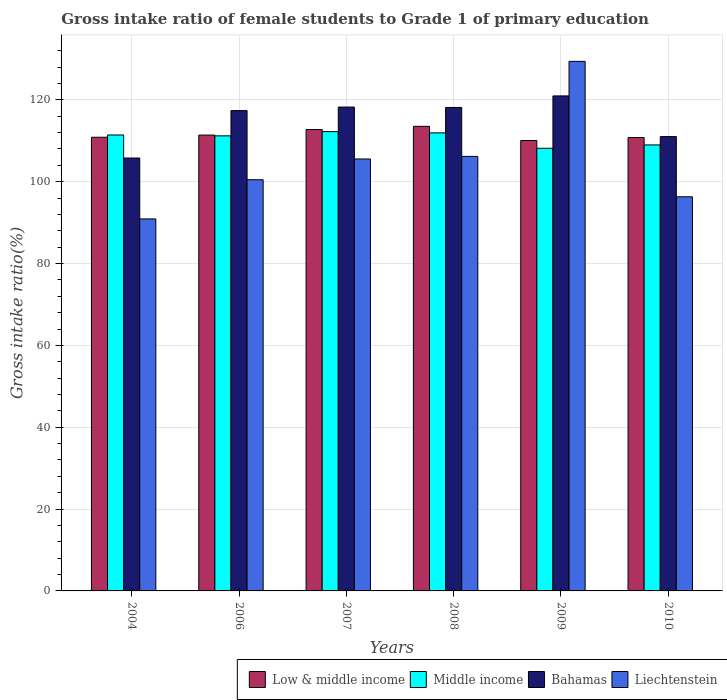Are the number of bars per tick equal to the number of legend labels?
Offer a terse response. Yes. Are the number of bars on each tick of the X-axis equal?
Make the answer very short. Yes. How many bars are there on the 3rd tick from the left?
Make the answer very short. 4. In how many cases, is the number of bars for a given year not equal to the number of legend labels?
Provide a succinct answer. 0. What is the gross intake ratio in Low & middle income in 2006?
Keep it short and to the point. 111.4. Across all years, what is the maximum gross intake ratio in Liechtenstein?
Offer a very short reply. 129.41. Across all years, what is the minimum gross intake ratio in Bahamas?
Make the answer very short. 105.79. What is the total gross intake ratio in Low & middle income in the graph?
Ensure brevity in your answer.  669.41. What is the difference between the gross intake ratio in Low & middle income in 2006 and that in 2008?
Offer a very short reply. -2.14. What is the difference between the gross intake ratio in Liechtenstein in 2007 and the gross intake ratio in Low & middle income in 2010?
Your answer should be compact. -5.24. What is the average gross intake ratio in Bahamas per year?
Give a very brief answer. 115.26. In the year 2006, what is the difference between the gross intake ratio in Middle income and gross intake ratio in Bahamas?
Provide a succinct answer. -6.17. In how many years, is the gross intake ratio in Low & middle income greater than 116 %?
Keep it short and to the point. 0. What is the ratio of the gross intake ratio in Low & middle income in 2004 to that in 2006?
Offer a terse response. 1. Is the difference between the gross intake ratio in Middle income in 2004 and 2007 greater than the difference between the gross intake ratio in Bahamas in 2004 and 2007?
Offer a terse response. Yes. What is the difference between the highest and the second highest gross intake ratio in Middle income?
Keep it short and to the point. 0.31. What is the difference between the highest and the lowest gross intake ratio in Middle income?
Your answer should be very brief. 4.08. In how many years, is the gross intake ratio in Middle income greater than the average gross intake ratio in Middle income taken over all years?
Ensure brevity in your answer.  4. Is the sum of the gross intake ratio in Middle income in 2009 and 2010 greater than the maximum gross intake ratio in Low & middle income across all years?
Ensure brevity in your answer.  Yes. Is it the case that in every year, the sum of the gross intake ratio in Liechtenstein and gross intake ratio in Low & middle income is greater than the sum of gross intake ratio in Bahamas and gross intake ratio in Middle income?
Keep it short and to the point. No. What does the 1st bar from the left in 2007 represents?
Offer a terse response. Low & middle income. Is it the case that in every year, the sum of the gross intake ratio in Middle income and gross intake ratio in Bahamas is greater than the gross intake ratio in Low & middle income?
Ensure brevity in your answer.  Yes. How many bars are there?
Provide a short and direct response. 24. Are all the bars in the graph horizontal?
Your response must be concise. No. What is the difference between two consecutive major ticks on the Y-axis?
Give a very brief answer. 20. Does the graph contain any zero values?
Keep it short and to the point. No. How many legend labels are there?
Give a very brief answer. 4. What is the title of the graph?
Make the answer very short. Gross intake ratio of female students to Grade 1 of primary education. What is the label or title of the X-axis?
Your answer should be compact. Years. What is the label or title of the Y-axis?
Make the answer very short. Gross intake ratio(%). What is the Gross intake ratio(%) of Low & middle income in 2004?
Your answer should be compact. 110.86. What is the Gross intake ratio(%) of Middle income in 2004?
Your answer should be very brief. 111.42. What is the Gross intake ratio(%) in Bahamas in 2004?
Provide a short and direct response. 105.79. What is the Gross intake ratio(%) of Liechtenstein in 2004?
Make the answer very short. 90.91. What is the Gross intake ratio(%) in Low & middle income in 2006?
Your answer should be compact. 111.4. What is the Gross intake ratio(%) in Middle income in 2006?
Offer a very short reply. 111.21. What is the Gross intake ratio(%) of Bahamas in 2006?
Your answer should be compact. 117.38. What is the Gross intake ratio(%) in Liechtenstein in 2006?
Keep it short and to the point. 100.48. What is the Gross intake ratio(%) in Low & middle income in 2007?
Keep it short and to the point. 112.75. What is the Gross intake ratio(%) in Middle income in 2007?
Offer a very short reply. 112.25. What is the Gross intake ratio(%) in Bahamas in 2007?
Provide a succinct answer. 118.24. What is the Gross intake ratio(%) in Liechtenstein in 2007?
Your answer should be compact. 105.56. What is the Gross intake ratio(%) of Low & middle income in 2008?
Your response must be concise. 113.53. What is the Gross intake ratio(%) in Middle income in 2008?
Ensure brevity in your answer.  111.93. What is the Gross intake ratio(%) in Bahamas in 2008?
Your response must be concise. 118.14. What is the Gross intake ratio(%) in Liechtenstein in 2008?
Offer a terse response. 106.19. What is the Gross intake ratio(%) of Low & middle income in 2009?
Offer a very short reply. 110.07. What is the Gross intake ratio(%) of Middle income in 2009?
Keep it short and to the point. 108.17. What is the Gross intake ratio(%) of Bahamas in 2009?
Provide a short and direct response. 120.97. What is the Gross intake ratio(%) of Liechtenstein in 2009?
Offer a terse response. 129.41. What is the Gross intake ratio(%) in Low & middle income in 2010?
Provide a short and direct response. 110.79. What is the Gross intake ratio(%) in Middle income in 2010?
Ensure brevity in your answer.  108.99. What is the Gross intake ratio(%) in Bahamas in 2010?
Provide a succinct answer. 111.02. What is the Gross intake ratio(%) in Liechtenstein in 2010?
Ensure brevity in your answer.  96.32. Across all years, what is the maximum Gross intake ratio(%) in Low & middle income?
Make the answer very short. 113.53. Across all years, what is the maximum Gross intake ratio(%) in Middle income?
Offer a terse response. 112.25. Across all years, what is the maximum Gross intake ratio(%) of Bahamas?
Your answer should be compact. 120.97. Across all years, what is the maximum Gross intake ratio(%) of Liechtenstein?
Offer a very short reply. 129.41. Across all years, what is the minimum Gross intake ratio(%) of Low & middle income?
Give a very brief answer. 110.07. Across all years, what is the minimum Gross intake ratio(%) in Middle income?
Offer a very short reply. 108.17. Across all years, what is the minimum Gross intake ratio(%) of Bahamas?
Your answer should be compact. 105.79. Across all years, what is the minimum Gross intake ratio(%) in Liechtenstein?
Make the answer very short. 90.91. What is the total Gross intake ratio(%) in Low & middle income in the graph?
Your response must be concise. 669.41. What is the total Gross intake ratio(%) in Middle income in the graph?
Give a very brief answer. 663.97. What is the total Gross intake ratio(%) of Bahamas in the graph?
Ensure brevity in your answer.  691.54. What is the total Gross intake ratio(%) of Liechtenstein in the graph?
Your response must be concise. 628.86. What is the difference between the Gross intake ratio(%) in Low & middle income in 2004 and that in 2006?
Your answer should be compact. -0.53. What is the difference between the Gross intake ratio(%) in Middle income in 2004 and that in 2006?
Your answer should be compact. 0.21. What is the difference between the Gross intake ratio(%) in Bahamas in 2004 and that in 2006?
Give a very brief answer. -11.59. What is the difference between the Gross intake ratio(%) in Liechtenstein in 2004 and that in 2006?
Your response must be concise. -9.57. What is the difference between the Gross intake ratio(%) of Low & middle income in 2004 and that in 2007?
Give a very brief answer. -1.89. What is the difference between the Gross intake ratio(%) in Middle income in 2004 and that in 2007?
Your answer should be very brief. -0.83. What is the difference between the Gross intake ratio(%) of Bahamas in 2004 and that in 2007?
Provide a succinct answer. -12.46. What is the difference between the Gross intake ratio(%) in Liechtenstein in 2004 and that in 2007?
Offer a very short reply. -14.65. What is the difference between the Gross intake ratio(%) of Low & middle income in 2004 and that in 2008?
Your response must be concise. -2.67. What is the difference between the Gross intake ratio(%) of Middle income in 2004 and that in 2008?
Make the answer very short. -0.51. What is the difference between the Gross intake ratio(%) of Bahamas in 2004 and that in 2008?
Provide a short and direct response. -12.36. What is the difference between the Gross intake ratio(%) of Liechtenstein in 2004 and that in 2008?
Keep it short and to the point. -15.28. What is the difference between the Gross intake ratio(%) in Low & middle income in 2004 and that in 2009?
Offer a terse response. 0.79. What is the difference between the Gross intake ratio(%) of Middle income in 2004 and that in 2009?
Keep it short and to the point. 3.25. What is the difference between the Gross intake ratio(%) of Bahamas in 2004 and that in 2009?
Make the answer very short. -15.18. What is the difference between the Gross intake ratio(%) of Liechtenstein in 2004 and that in 2009?
Give a very brief answer. -38.5. What is the difference between the Gross intake ratio(%) in Low & middle income in 2004 and that in 2010?
Provide a succinct answer. 0.07. What is the difference between the Gross intake ratio(%) of Middle income in 2004 and that in 2010?
Offer a terse response. 2.43. What is the difference between the Gross intake ratio(%) of Bahamas in 2004 and that in 2010?
Offer a terse response. -5.24. What is the difference between the Gross intake ratio(%) in Liechtenstein in 2004 and that in 2010?
Your answer should be compact. -5.41. What is the difference between the Gross intake ratio(%) in Low & middle income in 2006 and that in 2007?
Your answer should be very brief. -1.35. What is the difference between the Gross intake ratio(%) in Middle income in 2006 and that in 2007?
Offer a very short reply. -1.04. What is the difference between the Gross intake ratio(%) of Bahamas in 2006 and that in 2007?
Provide a short and direct response. -0.87. What is the difference between the Gross intake ratio(%) in Liechtenstein in 2006 and that in 2007?
Your answer should be compact. -5.07. What is the difference between the Gross intake ratio(%) in Low & middle income in 2006 and that in 2008?
Ensure brevity in your answer.  -2.14. What is the difference between the Gross intake ratio(%) of Middle income in 2006 and that in 2008?
Offer a terse response. -0.72. What is the difference between the Gross intake ratio(%) of Bahamas in 2006 and that in 2008?
Give a very brief answer. -0.76. What is the difference between the Gross intake ratio(%) in Liechtenstein in 2006 and that in 2008?
Your response must be concise. -5.7. What is the difference between the Gross intake ratio(%) in Low & middle income in 2006 and that in 2009?
Give a very brief answer. 1.33. What is the difference between the Gross intake ratio(%) in Middle income in 2006 and that in 2009?
Make the answer very short. 3.04. What is the difference between the Gross intake ratio(%) of Bahamas in 2006 and that in 2009?
Offer a very short reply. -3.59. What is the difference between the Gross intake ratio(%) in Liechtenstein in 2006 and that in 2009?
Provide a succinct answer. -28.93. What is the difference between the Gross intake ratio(%) in Low & middle income in 2006 and that in 2010?
Provide a succinct answer. 0.6. What is the difference between the Gross intake ratio(%) of Middle income in 2006 and that in 2010?
Offer a very short reply. 2.22. What is the difference between the Gross intake ratio(%) in Bahamas in 2006 and that in 2010?
Provide a short and direct response. 6.35. What is the difference between the Gross intake ratio(%) of Liechtenstein in 2006 and that in 2010?
Give a very brief answer. 4.17. What is the difference between the Gross intake ratio(%) of Low & middle income in 2007 and that in 2008?
Provide a short and direct response. -0.78. What is the difference between the Gross intake ratio(%) in Middle income in 2007 and that in 2008?
Give a very brief answer. 0.31. What is the difference between the Gross intake ratio(%) of Bahamas in 2007 and that in 2008?
Your answer should be compact. 0.1. What is the difference between the Gross intake ratio(%) in Liechtenstein in 2007 and that in 2008?
Make the answer very short. -0.63. What is the difference between the Gross intake ratio(%) of Low & middle income in 2007 and that in 2009?
Your answer should be very brief. 2.68. What is the difference between the Gross intake ratio(%) in Middle income in 2007 and that in 2009?
Your response must be concise. 4.08. What is the difference between the Gross intake ratio(%) in Bahamas in 2007 and that in 2009?
Offer a terse response. -2.72. What is the difference between the Gross intake ratio(%) in Liechtenstein in 2007 and that in 2009?
Offer a terse response. -23.86. What is the difference between the Gross intake ratio(%) of Low & middle income in 2007 and that in 2010?
Give a very brief answer. 1.96. What is the difference between the Gross intake ratio(%) of Middle income in 2007 and that in 2010?
Provide a succinct answer. 3.26. What is the difference between the Gross intake ratio(%) in Bahamas in 2007 and that in 2010?
Give a very brief answer. 7.22. What is the difference between the Gross intake ratio(%) of Liechtenstein in 2007 and that in 2010?
Your answer should be very brief. 9.24. What is the difference between the Gross intake ratio(%) in Low & middle income in 2008 and that in 2009?
Make the answer very short. 3.46. What is the difference between the Gross intake ratio(%) in Middle income in 2008 and that in 2009?
Your answer should be very brief. 3.76. What is the difference between the Gross intake ratio(%) in Bahamas in 2008 and that in 2009?
Give a very brief answer. -2.82. What is the difference between the Gross intake ratio(%) of Liechtenstein in 2008 and that in 2009?
Provide a succinct answer. -23.23. What is the difference between the Gross intake ratio(%) in Low & middle income in 2008 and that in 2010?
Provide a short and direct response. 2.74. What is the difference between the Gross intake ratio(%) of Middle income in 2008 and that in 2010?
Keep it short and to the point. 2.94. What is the difference between the Gross intake ratio(%) of Bahamas in 2008 and that in 2010?
Provide a short and direct response. 7.12. What is the difference between the Gross intake ratio(%) in Liechtenstein in 2008 and that in 2010?
Your response must be concise. 9.87. What is the difference between the Gross intake ratio(%) in Low & middle income in 2009 and that in 2010?
Make the answer very short. -0.72. What is the difference between the Gross intake ratio(%) in Middle income in 2009 and that in 2010?
Make the answer very short. -0.82. What is the difference between the Gross intake ratio(%) in Bahamas in 2009 and that in 2010?
Make the answer very short. 9.94. What is the difference between the Gross intake ratio(%) in Liechtenstein in 2009 and that in 2010?
Offer a very short reply. 33.1. What is the difference between the Gross intake ratio(%) of Low & middle income in 2004 and the Gross intake ratio(%) of Middle income in 2006?
Provide a short and direct response. -0.34. What is the difference between the Gross intake ratio(%) of Low & middle income in 2004 and the Gross intake ratio(%) of Bahamas in 2006?
Keep it short and to the point. -6.51. What is the difference between the Gross intake ratio(%) of Low & middle income in 2004 and the Gross intake ratio(%) of Liechtenstein in 2006?
Keep it short and to the point. 10.38. What is the difference between the Gross intake ratio(%) of Middle income in 2004 and the Gross intake ratio(%) of Bahamas in 2006?
Offer a terse response. -5.96. What is the difference between the Gross intake ratio(%) of Middle income in 2004 and the Gross intake ratio(%) of Liechtenstein in 2006?
Give a very brief answer. 10.94. What is the difference between the Gross intake ratio(%) of Bahamas in 2004 and the Gross intake ratio(%) of Liechtenstein in 2006?
Give a very brief answer. 5.3. What is the difference between the Gross intake ratio(%) of Low & middle income in 2004 and the Gross intake ratio(%) of Middle income in 2007?
Offer a terse response. -1.38. What is the difference between the Gross intake ratio(%) in Low & middle income in 2004 and the Gross intake ratio(%) in Bahamas in 2007?
Offer a terse response. -7.38. What is the difference between the Gross intake ratio(%) in Low & middle income in 2004 and the Gross intake ratio(%) in Liechtenstein in 2007?
Make the answer very short. 5.31. What is the difference between the Gross intake ratio(%) of Middle income in 2004 and the Gross intake ratio(%) of Bahamas in 2007?
Make the answer very short. -6.82. What is the difference between the Gross intake ratio(%) of Middle income in 2004 and the Gross intake ratio(%) of Liechtenstein in 2007?
Provide a short and direct response. 5.86. What is the difference between the Gross intake ratio(%) in Bahamas in 2004 and the Gross intake ratio(%) in Liechtenstein in 2007?
Provide a succinct answer. 0.23. What is the difference between the Gross intake ratio(%) in Low & middle income in 2004 and the Gross intake ratio(%) in Middle income in 2008?
Keep it short and to the point. -1.07. What is the difference between the Gross intake ratio(%) in Low & middle income in 2004 and the Gross intake ratio(%) in Bahamas in 2008?
Your response must be concise. -7.28. What is the difference between the Gross intake ratio(%) of Low & middle income in 2004 and the Gross intake ratio(%) of Liechtenstein in 2008?
Your answer should be compact. 4.68. What is the difference between the Gross intake ratio(%) in Middle income in 2004 and the Gross intake ratio(%) in Bahamas in 2008?
Give a very brief answer. -6.72. What is the difference between the Gross intake ratio(%) of Middle income in 2004 and the Gross intake ratio(%) of Liechtenstein in 2008?
Offer a very short reply. 5.23. What is the difference between the Gross intake ratio(%) in Bahamas in 2004 and the Gross intake ratio(%) in Liechtenstein in 2008?
Your response must be concise. -0.4. What is the difference between the Gross intake ratio(%) in Low & middle income in 2004 and the Gross intake ratio(%) in Middle income in 2009?
Ensure brevity in your answer.  2.69. What is the difference between the Gross intake ratio(%) of Low & middle income in 2004 and the Gross intake ratio(%) of Bahamas in 2009?
Your answer should be compact. -10.1. What is the difference between the Gross intake ratio(%) in Low & middle income in 2004 and the Gross intake ratio(%) in Liechtenstein in 2009?
Your answer should be compact. -18.55. What is the difference between the Gross intake ratio(%) in Middle income in 2004 and the Gross intake ratio(%) in Bahamas in 2009?
Your response must be concise. -9.55. What is the difference between the Gross intake ratio(%) in Middle income in 2004 and the Gross intake ratio(%) in Liechtenstein in 2009?
Make the answer very short. -17.99. What is the difference between the Gross intake ratio(%) in Bahamas in 2004 and the Gross intake ratio(%) in Liechtenstein in 2009?
Provide a succinct answer. -23.62. What is the difference between the Gross intake ratio(%) in Low & middle income in 2004 and the Gross intake ratio(%) in Middle income in 2010?
Give a very brief answer. 1.87. What is the difference between the Gross intake ratio(%) in Low & middle income in 2004 and the Gross intake ratio(%) in Bahamas in 2010?
Your answer should be compact. -0.16. What is the difference between the Gross intake ratio(%) in Low & middle income in 2004 and the Gross intake ratio(%) in Liechtenstein in 2010?
Ensure brevity in your answer.  14.55. What is the difference between the Gross intake ratio(%) of Middle income in 2004 and the Gross intake ratio(%) of Bahamas in 2010?
Keep it short and to the point. 0.4. What is the difference between the Gross intake ratio(%) of Middle income in 2004 and the Gross intake ratio(%) of Liechtenstein in 2010?
Your response must be concise. 15.1. What is the difference between the Gross intake ratio(%) in Bahamas in 2004 and the Gross intake ratio(%) in Liechtenstein in 2010?
Provide a short and direct response. 9.47. What is the difference between the Gross intake ratio(%) in Low & middle income in 2006 and the Gross intake ratio(%) in Middle income in 2007?
Offer a terse response. -0.85. What is the difference between the Gross intake ratio(%) of Low & middle income in 2006 and the Gross intake ratio(%) of Bahamas in 2007?
Keep it short and to the point. -6.85. What is the difference between the Gross intake ratio(%) in Low & middle income in 2006 and the Gross intake ratio(%) in Liechtenstein in 2007?
Your answer should be compact. 5.84. What is the difference between the Gross intake ratio(%) of Middle income in 2006 and the Gross intake ratio(%) of Bahamas in 2007?
Ensure brevity in your answer.  -7.04. What is the difference between the Gross intake ratio(%) of Middle income in 2006 and the Gross intake ratio(%) of Liechtenstein in 2007?
Your answer should be compact. 5.65. What is the difference between the Gross intake ratio(%) in Bahamas in 2006 and the Gross intake ratio(%) in Liechtenstein in 2007?
Provide a succinct answer. 11.82. What is the difference between the Gross intake ratio(%) in Low & middle income in 2006 and the Gross intake ratio(%) in Middle income in 2008?
Give a very brief answer. -0.53. What is the difference between the Gross intake ratio(%) of Low & middle income in 2006 and the Gross intake ratio(%) of Bahamas in 2008?
Keep it short and to the point. -6.75. What is the difference between the Gross intake ratio(%) in Low & middle income in 2006 and the Gross intake ratio(%) in Liechtenstein in 2008?
Give a very brief answer. 5.21. What is the difference between the Gross intake ratio(%) in Middle income in 2006 and the Gross intake ratio(%) in Bahamas in 2008?
Make the answer very short. -6.94. What is the difference between the Gross intake ratio(%) in Middle income in 2006 and the Gross intake ratio(%) in Liechtenstein in 2008?
Your answer should be very brief. 5.02. What is the difference between the Gross intake ratio(%) in Bahamas in 2006 and the Gross intake ratio(%) in Liechtenstein in 2008?
Ensure brevity in your answer.  11.19. What is the difference between the Gross intake ratio(%) in Low & middle income in 2006 and the Gross intake ratio(%) in Middle income in 2009?
Offer a terse response. 3.23. What is the difference between the Gross intake ratio(%) of Low & middle income in 2006 and the Gross intake ratio(%) of Bahamas in 2009?
Your response must be concise. -9.57. What is the difference between the Gross intake ratio(%) of Low & middle income in 2006 and the Gross intake ratio(%) of Liechtenstein in 2009?
Provide a short and direct response. -18.01. What is the difference between the Gross intake ratio(%) in Middle income in 2006 and the Gross intake ratio(%) in Bahamas in 2009?
Your response must be concise. -9.76. What is the difference between the Gross intake ratio(%) of Middle income in 2006 and the Gross intake ratio(%) of Liechtenstein in 2009?
Provide a short and direct response. -18.2. What is the difference between the Gross intake ratio(%) of Bahamas in 2006 and the Gross intake ratio(%) of Liechtenstein in 2009?
Offer a terse response. -12.03. What is the difference between the Gross intake ratio(%) of Low & middle income in 2006 and the Gross intake ratio(%) of Middle income in 2010?
Make the answer very short. 2.41. What is the difference between the Gross intake ratio(%) in Low & middle income in 2006 and the Gross intake ratio(%) in Bahamas in 2010?
Keep it short and to the point. 0.37. What is the difference between the Gross intake ratio(%) in Low & middle income in 2006 and the Gross intake ratio(%) in Liechtenstein in 2010?
Your answer should be very brief. 15.08. What is the difference between the Gross intake ratio(%) of Middle income in 2006 and the Gross intake ratio(%) of Bahamas in 2010?
Offer a very short reply. 0.18. What is the difference between the Gross intake ratio(%) of Middle income in 2006 and the Gross intake ratio(%) of Liechtenstein in 2010?
Offer a very short reply. 14.89. What is the difference between the Gross intake ratio(%) of Bahamas in 2006 and the Gross intake ratio(%) of Liechtenstein in 2010?
Give a very brief answer. 21.06. What is the difference between the Gross intake ratio(%) of Low & middle income in 2007 and the Gross intake ratio(%) of Middle income in 2008?
Make the answer very short. 0.82. What is the difference between the Gross intake ratio(%) in Low & middle income in 2007 and the Gross intake ratio(%) in Bahamas in 2008?
Offer a very short reply. -5.39. What is the difference between the Gross intake ratio(%) in Low & middle income in 2007 and the Gross intake ratio(%) in Liechtenstein in 2008?
Give a very brief answer. 6.57. What is the difference between the Gross intake ratio(%) of Middle income in 2007 and the Gross intake ratio(%) of Bahamas in 2008?
Ensure brevity in your answer.  -5.9. What is the difference between the Gross intake ratio(%) of Middle income in 2007 and the Gross intake ratio(%) of Liechtenstein in 2008?
Offer a very short reply. 6.06. What is the difference between the Gross intake ratio(%) of Bahamas in 2007 and the Gross intake ratio(%) of Liechtenstein in 2008?
Your answer should be very brief. 12.06. What is the difference between the Gross intake ratio(%) in Low & middle income in 2007 and the Gross intake ratio(%) in Middle income in 2009?
Your response must be concise. 4.58. What is the difference between the Gross intake ratio(%) of Low & middle income in 2007 and the Gross intake ratio(%) of Bahamas in 2009?
Offer a terse response. -8.21. What is the difference between the Gross intake ratio(%) of Low & middle income in 2007 and the Gross intake ratio(%) of Liechtenstein in 2009?
Provide a short and direct response. -16.66. What is the difference between the Gross intake ratio(%) of Middle income in 2007 and the Gross intake ratio(%) of Bahamas in 2009?
Offer a terse response. -8.72. What is the difference between the Gross intake ratio(%) in Middle income in 2007 and the Gross intake ratio(%) in Liechtenstein in 2009?
Your response must be concise. -17.17. What is the difference between the Gross intake ratio(%) of Bahamas in 2007 and the Gross intake ratio(%) of Liechtenstein in 2009?
Offer a terse response. -11.17. What is the difference between the Gross intake ratio(%) in Low & middle income in 2007 and the Gross intake ratio(%) in Middle income in 2010?
Offer a terse response. 3.76. What is the difference between the Gross intake ratio(%) of Low & middle income in 2007 and the Gross intake ratio(%) of Bahamas in 2010?
Provide a succinct answer. 1.73. What is the difference between the Gross intake ratio(%) in Low & middle income in 2007 and the Gross intake ratio(%) in Liechtenstein in 2010?
Give a very brief answer. 16.44. What is the difference between the Gross intake ratio(%) in Middle income in 2007 and the Gross intake ratio(%) in Bahamas in 2010?
Offer a very short reply. 1.22. What is the difference between the Gross intake ratio(%) of Middle income in 2007 and the Gross intake ratio(%) of Liechtenstein in 2010?
Make the answer very short. 15.93. What is the difference between the Gross intake ratio(%) of Bahamas in 2007 and the Gross intake ratio(%) of Liechtenstein in 2010?
Provide a short and direct response. 21.93. What is the difference between the Gross intake ratio(%) in Low & middle income in 2008 and the Gross intake ratio(%) in Middle income in 2009?
Keep it short and to the point. 5.36. What is the difference between the Gross intake ratio(%) in Low & middle income in 2008 and the Gross intake ratio(%) in Bahamas in 2009?
Your response must be concise. -7.43. What is the difference between the Gross intake ratio(%) of Low & middle income in 2008 and the Gross intake ratio(%) of Liechtenstein in 2009?
Your answer should be very brief. -15.88. What is the difference between the Gross intake ratio(%) of Middle income in 2008 and the Gross intake ratio(%) of Bahamas in 2009?
Ensure brevity in your answer.  -9.03. What is the difference between the Gross intake ratio(%) in Middle income in 2008 and the Gross intake ratio(%) in Liechtenstein in 2009?
Offer a terse response. -17.48. What is the difference between the Gross intake ratio(%) of Bahamas in 2008 and the Gross intake ratio(%) of Liechtenstein in 2009?
Your answer should be very brief. -11.27. What is the difference between the Gross intake ratio(%) in Low & middle income in 2008 and the Gross intake ratio(%) in Middle income in 2010?
Give a very brief answer. 4.54. What is the difference between the Gross intake ratio(%) in Low & middle income in 2008 and the Gross intake ratio(%) in Bahamas in 2010?
Provide a short and direct response. 2.51. What is the difference between the Gross intake ratio(%) of Low & middle income in 2008 and the Gross intake ratio(%) of Liechtenstein in 2010?
Your response must be concise. 17.22. What is the difference between the Gross intake ratio(%) of Middle income in 2008 and the Gross intake ratio(%) of Bahamas in 2010?
Your answer should be compact. 0.91. What is the difference between the Gross intake ratio(%) in Middle income in 2008 and the Gross intake ratio(%) in Liechtenstein in 2010?
Your answer should be very brief. 15.62. What is the difference between the Gross intake ratio(%) of Bahamas in 2008 and the Gross intake ratio(%) of Liechtenstein in 2010?
Keep it short and to the point. 21.83. What is the difference between the Gross intake ratio(%) of Low & middle income in 2009 and the Gross intake ratio(%) of Middle income in 2010?
Offer a terse response. 1.08. What is the difference between the Gross intake ratio(%) in Low & middle income in 2009 and the Gross intake ratio(%) in Bahamas in 2010?
Your answer should be very brief. -0.95. What is the difference between the Gross intake ratio(%) in Low & middle income in 2009 and the Gross intake ratio(%) in Liechtenstein in 2010?
Keep it short and to the point. 13.76. What is the difference between the Gross intake ratio(%) of Middle income in 2009 and the Gross intake ratio(%) of Bahamas in 2010?
Make the answer very short. -2.86. What is the difference between the Gross intake ratio(%) of Middle income in 2009 and the Gross intake ratio(%) of Liechtenstein in 2010?
Offer a very short reply. 11.85. What is the difference between the Gross intake ratio(%) of Bahamas in 2009 and the Gross intake ratio(%) of Liechtenstein in 2010?
Provide a short and direct response. 24.65. What is the average Gross intake ratio(%) of Low & middle income per year?
Offer a terse response. 111.57. What is the average Gross intake ratio(%) in Middle income per year?
Keep it short and to the point. 110.66. What is the average Gross intake ratio(%) of Bahamas per year?
Your response must be concise. 115.26. What is the average Gross intake ratio(%) in Liechtenstein per year?
Your answer should be very brief. 104.81. In the year 2004, what is the difference between the Gross intake ratio(%) in Low & middle income and Gross intake ratio(%) in Middle income?
Keep it short and to the point. -0.56. In the year 2004, what is the difference between the Gross intake ratio(%) in Low & middle income and Gross intake ratio(%) in Bahamas?
Your answer should be very brief. 5.08. In the year 2004, what is the difference between the Gross intake ratio(%) in Low & middle income and Gross intake ratio(%) in Liechtenstein?
Ensure brevity in your answer.  19.95. In the year 2004, what is the difference between the Gross intake ratio(%) of Middle income and Gross intake ratio(%) of Bahamas?
Provide a short and direct response. 5.63. In the year 2004, what is the difference between the Gross intake ratio(%) of Middle income and Gross intake ratio(%) of Liechtenstein?
Offer a terse response. 20.51. In the year 2004, what is the difference between the Gross intake ratio(%) in Bahamas and Gross intake ratio(%) in Liechtenstein?
Your response must be concise. 14.88. In the year 2006, what is the difference between the Gross intake ratio(%) of Low & middle income and Gross intake ratio(%) of Middle income?
Provide a succinct answer. 0.19. In the year 2006, what is the difference between the Gross intake ratio(%) in Low & middle income and Gross intake ratio(%) in Bahamas?
Ensure brevity in your answer.  -5.98. In the year 2006, what is the difference between the Gross intake ratio(%) of Low & middle income and Gross intake ratio(%) of Liechtenstein?
Your response must be concise. 10.91. In the year 2006, what is the difference between the Gross intake ratio(%) in Middle income and Gross intake ratio(%) in Bahamas?
Your answer should be compact. -6.17. In the year 2006, what is the difference between the Gross intake ratio(%) of Middle income and Gross intake ratio(%) of Liechtenstein?
Your response must be concise. 10.72. In the year 2006, what is the difference between the Gross intake ratio(%) of Bahamas and Gross intake ratio(%) of Liechtenstein?
Your response must be concise. 16.9. In the year 2007, what is the difference between the Gross intake ratio(%) of Low & middle income and Gross intake ratio(%) of Middle income?
Keep it short and to the point. 0.51. In the year 2007, what is the difference between the Gross intake ratio(%) of Low & middle income and Gross intake ratio(%) of Bahamas?
Offer a very short reply. -5.49. In the year 2007, what is the difference between the Gross intake ratio(%) in Low & middle income and Gross intake ratio(%) in Liechtenstein?
Give a very brief answer. 7.2. In the year 2007, what is the difference between the Gross intake ratio(%) in Middle income and Gross intake ratio(%) in Bahamas?
Provide a short and direct response. -6. In the year 2007, what is the difference between the Gross intake ratio(%) of Middle income and Gross intake ratio(%) of Liechtenstein?
Your response must be concise. 6.69. In the year 2007, what is the difference between the Gross intake ratio(%) of Bahamas and Gross intake ratio(%) of Liechtenstein?
Keep it short and to the point. 12.69. In the year 2008, what is the difference between the Gross intake ratio(%) in Low & middle income and Gross intake ratio(%) in Middle income?
Offer a very short reply. 1.6. In the year 2008, what is the difference between the Gross intake ratio(%) in Low & middle income and Gross intake ratio(%) in Bahamas?
Your answer should be compact. -4.61. In the year 2008, what is the difference between the Gross intake ratio(%) in Low & middle income and Gross intake ratio(%) in Liechtenstein?
Offer a terse response. 7.35. In the year 2008, what is the difference between the Gross intake ratio(%) of Middle income and Gross intake ratio(%) of Bahamas?
Offer a terse response. -6.21. In the year 2008, what is the difference between the Gross intake ratio(%) of Middle income and Gross intake ratio(%) of Liechtenstein?
Keep it short and to the point. 5.75. In the year 2008, what is the difference between the Gross intake ratio(%) of Bahamas and Gross intake ratio(%) of Liechtenstein?
Your response must be concise. 11.96. In the year 2009, what is the difference between the Gross intake ratio(%) of Low & middle income and Gross intake ratio(%) of Middle income?
Your response must be concise. 1.9. In the year 2009, what is the difference between the Gross intake ratio(%) in Low & middle income and Gross intake ratio(%) in Bahamas?
Provide a succinct answer. -10.89. In the year 2009, what is the difference between the Gross intake ratio(%) of Low & middle income and Gross intake ratio(%) of Liechtenstein?
Provide a short and direct response. -19.34. In the year 2009, what is the difference between the Gross intake ratio(%) of Middle income and Gross intake ratio(%) of Bahamas?
Provide a succinct answer. -12.8. In the year 2009, what is the difference between the Gross intake ratio(%) of Middle income and Gross intake ratio(%) of Liechtenstein?
Make the answer very short. -21.24. In the year 2009, what is the difference between the Gross intake ratio(%) in Bahamas and Gross intake ratio(%) in Liechtenstein?
Ensure brevity in your answer.  -8.45. In the year 2010, what is the difference between the Gross intake ratio(%) in Low & middle income and Gross intake ratio(%) in Middle income?
Keep it short and to the point. 1.8. In the year 2010, what is the difference between the Gross intake ratio(%) in Low & middle income and Gross intake ratio(%) in Bahamas?
Keep it short and to the point. -0.23. In the year 2010, what is the difference between the Gross intake ratio(%) in Low & middle income and Gross intake ratio(%) in Liechtenstein?
Offer a very short reply. 14.48. In the year 2010, what is the difference between the Gross intake ratio(%) in Middle income and Gross intake ratio(%) in Bahamas?
Your response must be concise. -2.03. In the year 2010, what is the difference between the Gross intake ratio(%) of Middle income and Gross intake ratio(%) of Liechtenstein?
Make the answer very short. 12.67. In the year 2010, what is the difference between the Gross intake ratio(%) in Bahamas and Gross intake ratio(%) in Liechtenstein?
Your answer should be very brief. 14.71. What is the ratio of the Gross intake ratio(%) of Bahamas in 2004 to that in 2006?
Offer a terse response. 0.9. What is the ratio of the Gross intake ratio(%) in Liechtenstein in 2004 to that in 2006?
Offer a terse response. 0.9. What is the ratio of the Gross intake ratio(%) in Low & middle income in 2004 to that in 2007?
Offer a terse response. 0.98. What is the ratio of the Gross intake ratio(%) of Bahamas in 2004 to that in 2007?
Make the answer very short. 0.89. What is the ratio of the Gross intake ratio(%) of Liechtenstein in 2004 to that in 2007?
Ensure brevity in your answer.  0.86. What is the ratio of the Gross intake ratio(%) of Low & middle income in 2004 to that in 2008?
Keep it short and to the point. 0.98. What is the ratio of the Gross intake ratio(%) in Bahamas in 2004 to that in 2008?
Provide a succinct answer. 0.9. What is the ratio of the Gross intake ratio(%) of Liechtenstein in 2004 to that in 2008?
Your response must be concise. 0.86. What is the ratio of the Gross intake ratio(%) in Middle income in 2004 to that in 2009?
Your answer should be very brief. 1.03. What is the ratio of the Gross intake ratio(%) in Bahamas in 2004 to that in 2009?
Offer a very short reply. 0.87. What is the ratio of the Gross intake ratio(%) in Liechtenstein in 2004 to that in 2009?
Your answer should be very brief. 0.7. What is the ratio of the Gross intake ratio(%) in Middle income in 2004 to that in 2010?
Give a very brief answer. 1.02. What is the ratio of the Gross intake ratio(%) of Bahamas in 2004 to that in 2010?
Your response must be concise. 0.95. What is the ratio of the Gross intake ratio(%) in Liechtenstein in 2004 to that in 2010?
Your answer should be compact. 0.94. What is the ratio of the Gross intake ratio(%) in Middle income in 2006 to that in 2007?
Offer a terse response. 0.99. What is the ratio of the Gross intake ratio(%) in Bahamas in 2006 to that in 2007?
Your response must be concise. 0.99. What is the ratio of the Gross intake ratio(%) in Liechtenstein in 2006 to that in 2007?
Make the answer very short. 0.95. What is the ratio of the Gross intake ratio(%) in Low & middle income in 2006 to that in 2008?
Keep it short and to the point. 0.98. What is the ratio of the Gross intake ratio(%) of Middle income in 2006 to that in 2008?
Your answer should be very brief. 0.99. What is the ratio of the Gross intake ratio(%) of Bahamas in 2006 to that in 2008?
Ensure brevity in your answer.  0.99. What is the ratio of the Gross intake ratio(%) in Liechtenstein in 2006 to that in 2008?
Keep it short and to the point. 0.95. What is the ratio of the Gross intake ratio(%) in Middle income in 2006 to that in 2009?
Provide a succinct answer. 1.03. What is the ratio of the Gross intake ratio(%) of Bahamas in 2006 to that in 2009?
Keep it short and to the point. 0.97. What is the ratio of the Gross intake ratio(%) in Liechtenstein in 2006 to that in 2009?
Your response must be concise. 0.78. What is the ratio of the Gross intake ratio(%) in Middle income in 2006 to that in 2010?
Your response must be concise. 1.02. What is the ratio of the Gross intake ratio(%) in Bahamas in 2006 to that in 2010?
Make the answer very short. 1.06. What is the ratio of the Gross intake ratio(%) in Liechtenstein in 2006 to that in 2010?
Offer a very short reply. 1.04. What is the ratio of the Gross intake ratio(%) of Low & middle income in 2007 to that in 2008?
Your response must be concise. 0.99. What is the ratio of the Gross intake ratio(%) in Middle income in 2007 to that in 2008?
Offer a terse response. 1. What is the ratio of the Gross intake ratio(%) in Liechtenstein in 2007 to that in 2008?
Ensure brevity in your answer.  0.99. What is the ratio of the Gross intake ratio(%) in Low & middle income in 2007 to that in 2009?
Ensure brevity in your answer.  1.02. What is the ratio of the Gross intake ratio(%) of Middle income in 2007 to that in 2009?
Provide a succinct answer. 1.04. What is the ratio of the Gross intake ratio(%) in Bahamas in 2007 to that in 2009?
Offer a very short reply. 0.98. What is the ratio of the Gross intake ratio(%) of Liechtenstein in 2007 to that in 2009?
Ensure brevity in your answer.  0.82. What is the ratio of the Gross intake ratio(%) of Low & middle income in 2007 to that in 2010?
Make the answer very short. 1.02. What is the ratio of the Gross intake ratio(%) in Middle income in 2007 to that in 2010?
Give a very brief answer. 1.03. What is the ratio of the Gross intake ratio(%) of Bahamas in 2007 to that in 2010?
Keep it short and to the point. 1.06. What is the ratio of the Gross intake ratio(%) in Liechtenstein in 2007 to that in 2010?
Provide a succinct answer. 1.1. What is the ratio of the Gross intake ratio(%) of Low & middle income in 2008 to that in 2009?
Your answer should be compact. 1.03. What is the ratio of the Gross intake ratio(%) in Middle income in 2008 to that in 2009?
Your answer should be very brief. 1.03. What is the ratio of the Gross intake ratio(%) in Bahamas in 2008 to that in 2009?
Give a very brief answer. 0.98. What is the ratio of the Gross intake ratio(%) in Liechtenstein in 2008 to that in 2009?
Provide a short and direct response. 0.82. What is the ratio of the Gross intake ratio(%) of Low & middle income in 2008 to that in 2010?
Offer a terse response. 1.02. What is the ratio of the Gross intake ratio(%) in Middle income in 2008 to that in 2010?
Offer a very short reply. 1.03. What is the ratio of the Gross intake ratio(%) in Bahamas in 2008 to that in 2010?
Provide a succinct answer. 1.06. What is the ratio of the Gross intake ratio(%) in Liechtenstein in 2008 to that in 2010?
Give a very brief answer. 1.1. What is the ratio of the Gross intake ratio(%) in Low & middle income in 2009 to that in 2010?
Your answer should be very brief. 0.99. What is the ratio of the Gross intake ratio(%) of Middle income in 2009 to that in 2010?
Your answer should be compact. 0.99. What is the ratio of the Gross intake ratio(%) of Bahamas in 2009 to that in 2010?
Provide a short and direct response. 1.09. What is the ratio of the Gross intake ratio(%) of Liechtenstein in 2009 to that in 2010?
Offer a terse response. 1.34. What is the difference between the highest and the second highest Gross intake ratio(%) in Low & middle income?
Your answer should be very brief. 0.78. What is the difference between the highest and the second highest Gross intake ratio(%) in Middle income?
Provide a short and direct response. 0.31. What is the difference between the highest and the second highest Gross intake ratio(%) in Bahamas?
Your answer should be very brief. 2.72. What is the difference between the highest and the second highest Gross intake ratio(%) of Liechtenstein?
Keep it short and to the point. 23.23. What is the difference between the highest and the lowest Gross intake ratio(%) of Low & middle income?
Your answer should be very brief. 3.46. What is the difference between the highest and the lowest Gross intake ratio(%) in Middle income?
Keep it short and to the point. 4.08. What is the difference between the highest and the lowest Gross intake ratio(%) in Bahamas?
Offer a very short reply. 15.18. What is the difference between the highest and the lowest Gross intake ratio(%) in Liechtenstein?
Your response must be concise. 38.5. 